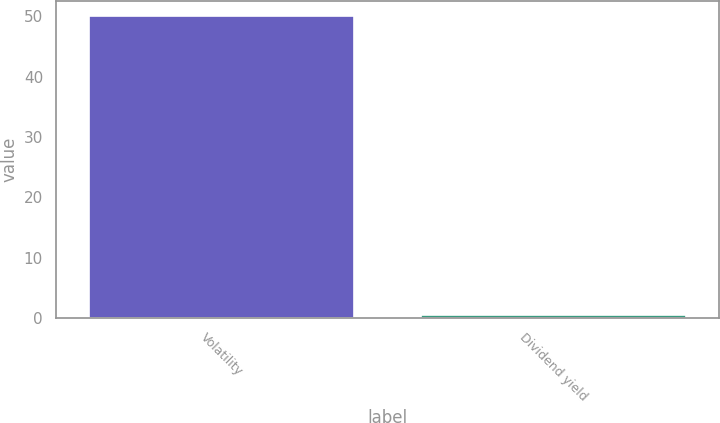Convert chart to OTSL. <chart><loc_0><loc_0><loc_500><loc_500><bar_chart><fcel>Volatility<fcel>Dividend yield<nl><fcel>50<fcel>0.5<nl></chart> 